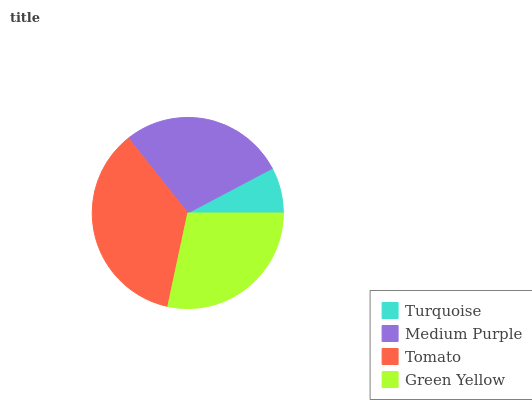Is Turquoise the minimum?
Answer yes or no. Yes. Is Tomato the maximum?
Answer yes or no. Yes. Is Medium Purple the minimum?
Answer yes or no. No. Is Medium Purple the maximum?
Answer yes or no. No. Is Medium Purple greater than Turquoise?
Answer yes or no. Yes. Is Turquoise less than Medium Purple?
Answer yes or no. Yes. Is Turquoise greater than Medium Purple?
Answer yes or no. No. Is Medium Purple less than Turquoise?
Answer yes or no. No. Is Green Yellow the high median?
Answer yes or no. Yes. Is Medium Purple the low median?
Answer yes or no. Yes. Is Turquoise the high median?
Answer yes or no. No. Is Green Yellow the low median?
Answer yes or no. No. 